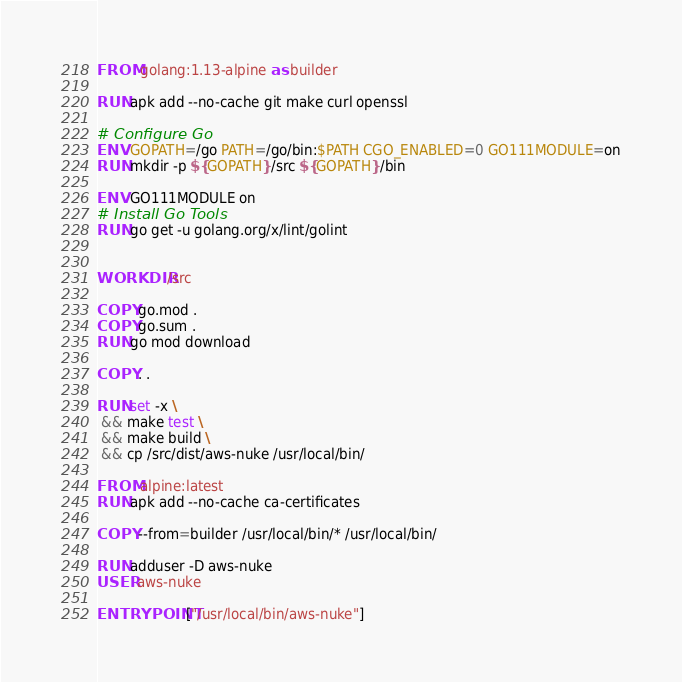Convert code to text. <code><loc_0><loc_0><loc_500><loc_500><_Dockerfile_>FROM golang:1.13-alpine as builder

RUN apk add --no-cache git make curl openssl

# Configure Go
ENV GOPATH=/go PATH=/go/bin:$PATH CGO_ENABLED=0 GO111MODULE=on
RUN mkdir -p ${GOPATH}/src ${GOPATH}/bin

ENV GO111MODULE on
# Install Go Tools
RUN go get -u golang.org/x/lint/golint


WORKDIR /src

COPY go.mod .
COPY go.sum .
RUN go mod download

COPY . .

RUN set -x \
 && make test \
 && make build \
 && cp /src/dist/aws-nuke /usr/local/bin/

FROM alpine:latest
RUN apk add --no-cache ca-certificates

COPY --from=builder /usr/local/bin/* /usr/local/bin/

RUN adduser -D aws-nuke
USER aws-nuke

ENTRYPOINT ["/usr/local/bin/aws-nuke"]
</code> 